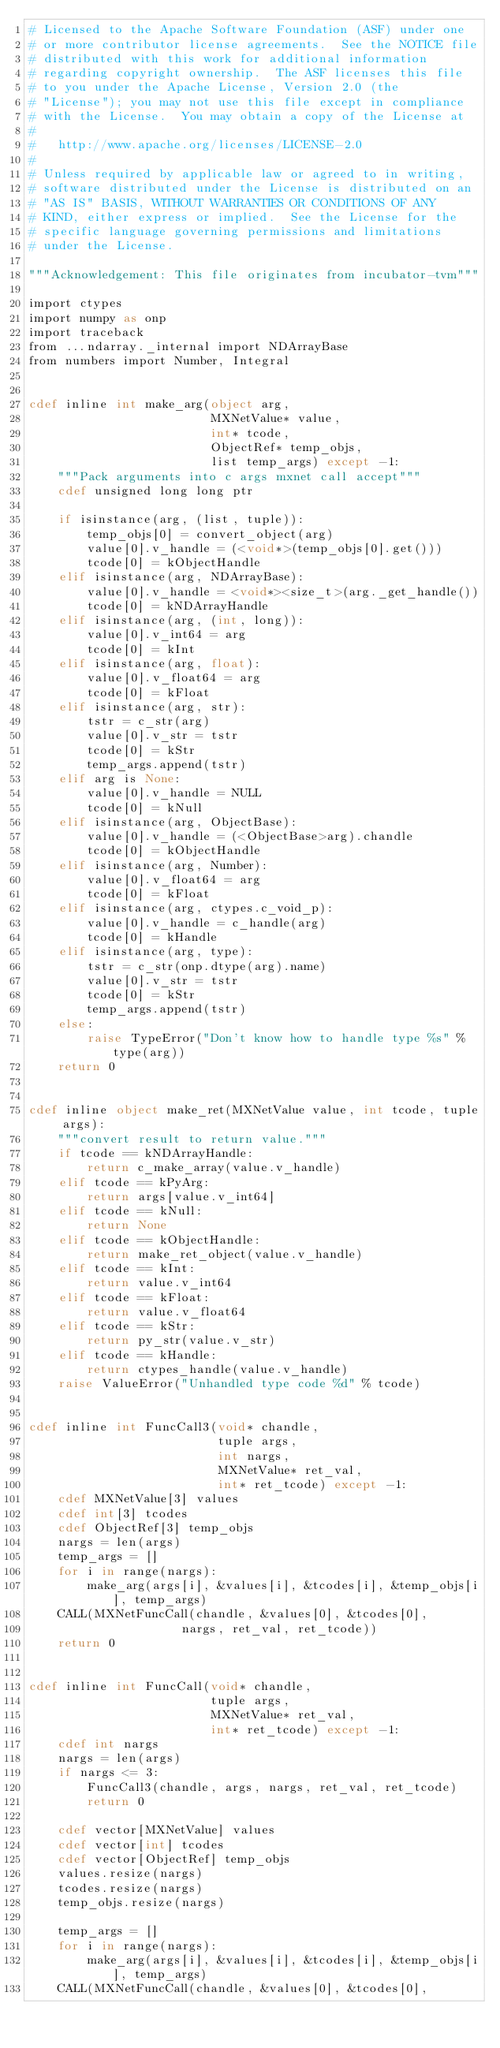Convert code to text. <code><loc_0><loc_0><loc_500><loc_500><_Cython_># Licensed to the Apache Software Foundation (ASF) under one
# or more contributor license agreements.  See the NOTICE file
# distributed with this work for additional information
# regarding copyright ownership.  The ASF licenses this file
# to you under the Apache License, Version 2.0 (the
# "License"); you may not use this file except in compliance
# with the License.  You may obtain a copy of the License at
#
#   http://www.apache.org/licenses/LICENSE-2.0
#
# Unless required by applicable law or agreed to in writing,
# software distributed under the License is distributed on an
# "AS IS" BASIS, WITHOUT WARRANTIES OR CONDITIONS OF ANY
# KIND, either express or implied.  See the License for the
# specific language governing permissions and limitations
# under the License.

"""Acknowledgement: This file originates from incubator-tvm"""

import ctypes
import numpy as onp
import traceback
from ...ndarray._internal import NDArrayBase
from numbers import Number, Integral


cdef inline int make_arg(object arg,
                         MXNetValue* value,
                         int* tcode,
                         ObjectRef* temp_objs,
                         list temp_args) except -1:
    """Pack arguments into c args mxnet call accept"""
    cdef unsigned long long ptr

    if isinstance(arg, (list, tuple)):
        temp_objs[0] = convert_object(arg)
        value[0].v_handle = (<void*>(temp_objs[0].get()))
        tcode[0] = kObjectHandle
    elif isinstance(arg, NDArrayBase):
        value[0].v_handle = <void*><size_t>(arg._get_handle())
        tcode[0] = kNDArrayHandle
    elif isinstance(arg, (int, long)):
        value[0].v_int64 = arg
        tcode[0] = kInt
    elif isinstance(arg, float):
        value[0].v_float64 = arg
        tcode[0] = kFloat
    elif isinstance(arg, str):
        tstr = c_str(arg)
        value[0].v_str = tstr
        tcode[0] = kStr
        temp_args.append(tstr)
    elif arg is None:
        value[0].v_handle = NULL
        tcode[0] = kNull
    elif isinstance(arg, ObjectBase):
        value[0].v_handle = (<ObjectBase>arg).chandle
        tcode[0] = kObjectHandle
    elif isinstance(arg, Number):
        value[0].v_float64 = arg
        tcode[0] = kFloat
    elif isinstance(arg, ctypes.c_void_p):
        value[0].v_handle = c_handle(arg)
        tcode[0] = kHandle
    elif isinstance(arg, type):
        tstr = c_str(onp.dtype(arg).name)
        value[0].v_str = tstr
        tcode[0] = kStr
        temp_args.append(tstr)
    else:
        raise TypeError("Don't know how to handle type %s" % type(arg))
    return 0


cdef inline object make_ret(MXNetValue value, int tcode, tuple args):
    """convert result to return value."""
    if tcode == kNDArrayHandle:
        return c_make_array(value.v_handle)
    elif tcode == kPyArg:
        return args[value.v_int64]
    elif tcode == kNull:
        return None
    elif tcode == kObjectHandle:
        return make_ret_object(value.v_handle)
    elif tcode == kInt:
        return value.v_int64
    elif tcode == kFloat:
        return value.v_float64
    elif tcode == kStr:
        return py_str(value.v_str)
    elif tcode == kHandle:
        return ctypes_handle(value.v_handle)
    raise ValueError("Unhandled type code %d" % tcode)


cdef inline int FuncCall3(void* chandle,
                          tuple args,
                          int nargs,
                          MXNetValue* ret_val,
                          int* ret_tcode) except -1:
    cdef MXNetValue[3] values
    cdef int[3] tcodes
    cdef ObjectRef[3] temp_objs
    nargs = len(args)
    temp_args = []
    for i in range(nargs):
        make_arg(args[i], &values[i], &tcodes[i], &temp_objs[i], temp_args)
    CALL(MXNetFuncCall(chandle, &values[0], &tcodes[0],
                     nargs, ret_val, ret_tcode))
    return 0


cdef inline int FuncCall(void* chandle,
                         tuple args,
                         MXNetValue* ret_val,
                         int* ret_tcode) except -1:
    cdef int nargs
    nargs = len(args)
    if nargs <= 3:
        FuncCall3(chandle, args, nargs, ret_val, ret_tcode)
        return 0

    cdef vector[MXNetValue] values
    cdef vector[int] tcodes
    cdef vector[ObjectRef] temp_objs
    values.resize(nargs)
    tcodes.resize(nargs)
    temp_objs.resize(nargs)

    temp_args = []
    for i in range(nargs):
        make_arg(args[i], &values[i], &tcodes[i], &temp_objs[i], temp_args)
    CALL(MXNetFuncCall(chandle, &values[0], &tcodes[0],</code> 